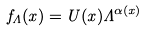<formula> <loc_0><loc_0><loc_500><loc_500>f _ { \Lambda } ( x ) = U ( x ) \Lambda ^ { \alpha ( x ) }</formula> 